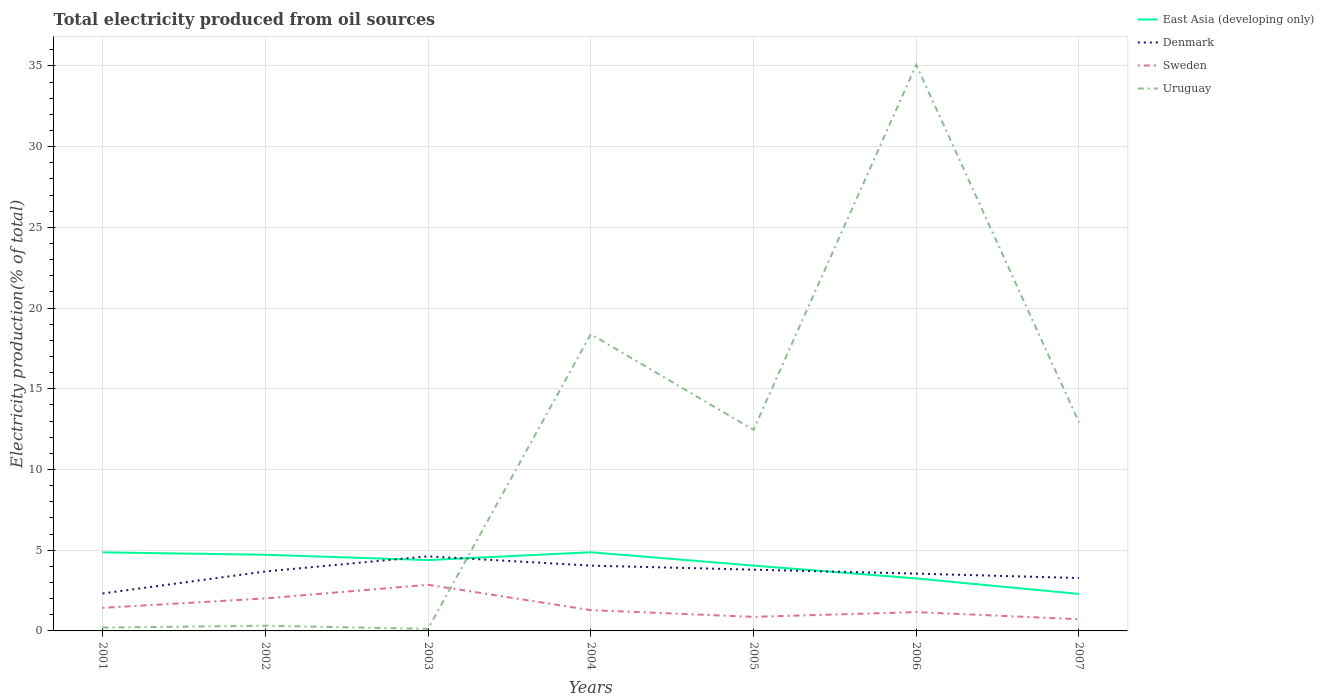Does the line corresponding to East Asia (developing only) intersect with the line corresponding to Uruguay?
Offer a terse response. Yes. Across all years, what is the maximum total electricity produced in East Asia (developing only)?
Give a very brief answer. 2.29. What is the total total electricity produced in Denmark in the graph?
Provide a short and direct response. -0.36. What is the difference between the highest and the second highest total electricity produced in Uruguay?
Make the answer very short. 34.94. Are the values on the major ticks of Y-axis written in scientific E-notation?
Make the answer very short. No. Does the graph contain any zero values?
Give a very brief answer. No. Does the graph contain grids?
Your answer should be very brief. Yes. Where does the legend appear in the graph?
Your response must be concise. Top right. What is the title of the graph?
Give a very brief answer. Total electricity produced from oil sources. What is the label or title of the X-axis?
Your answer should be very brief. Years. What is the Electricity production(% of total) in East Asia (developing only) in 2001?
Provide a short and direct response. 4.87. What is the Electricity production(% of total) in Denmark in 2001?
Offer a very short reply. 2.32. What is the Electricity production(% of total) of Sweden in 2001?
Provide a succinct answer. 1.43. What is the Electricity production(% of total) of Uruguay in 2001?
Your response must be concise. 0.21. What is the Electricity production(% of total) in East Asia (developing only) in 2002?
Make the answer very short. 4.72. What is the Electricity production(% of total) in Denmark in 2002?
Your answer should be very brief. 3.68. What is the Electricity production(% of total) in Sweden in 2002?
Your answer should be very brief. 2.01. What is the Electricity production(% of total) in Uruguay in 2002?
Keep it short and to the point. 0.32. What is the Electricity production(% of total) of East Asia (developing only) in 2003?
Your answer should be very brief. 4.39. What is the Electricity production(% of total) in Denmark in 2003?
Provide a short and direct response. 4.62. What is the Electricity production(% of total) in Sweden in 2003?
Your answer should be compact. 2.86. What is the Electricity production(% of total) in Uruguay in 2003?
Your answer should be compact. 0.13. What is the Electricity production(% of total) in East Asia (developing only) in 2004?
Provide a succinct answer. 4.87. What is the Electricity production(% of total) in Denmark in 2004?
Make the answer very short. 4.05. What is the Electricity production(% of total) in Sweden in 2004?
Provide a succinct answer. 1.29. What is the Electricity production(% of total) of Uruguay in 2004?
Your answer should be very brief. 18.38. What is the Electricity production(% of total) in East Asia (developing only) in 2005?
Offer a very short reply. 4.05. What is the Electricity production(% of total) of Denmark in 2005?
Offer a very short reply. 3.79. What is the Electricity production(% of total) of Sweden in 2005?
Give a very brief answer. 0.87. What is the Electricity production(% of total) in Uruguay in 2005?
Keep it short and to the point. 12.46. What is the Electricity production(% of total) of East Asia (developing only) in 2006?
Provide a short and direct response. 3.25. What is the Electricity production(% of total) in Denmark in 2006?
Provide a short and direct response. 3.55. What is the Electricity production(% of total) of Sweden in 2006?
Provide a short and direct response. 1.16. What is the Electricity production(% of total) of Uruguay in 2006?
Offer a terse response. 35.07. What is the Electricity production(% of total) of East Asia (developing only) in 2007?
Make the answer very short. 2.29. What is the Electricity production(% of total) in Denmark in 2007?
Provide a short and direct response. 3.28. What is the Electricity production(% of total) of Sweden in 2007?
Your answer should be very brief. 0.72. What is the Electricity production(% of total) of Uruguay in 2007?
Your response must be concise. 12.92. Across all years, what is the maximum Electricity production(% of total) in East Asia (developing only)?
Ensure brevity in your answer.  4.87. Across all years, what is the maximum Electricity production(% of total) of Denmark?
Make the answer very short. 4.62. Across all years, what is the maximum Electricity production(% of total) of Sweden?
Ensure brevity in your answer.  2.86. Across all years, what is the maximum Electricity production(% of total) of Uruguay?
Your answer should be very brief. 35.07. Across all years, what is the minimum Electricity production(% of total) of East Asia (developing only)?
Provide a succinct answer. 2.29. Across all years, what is the minimum Electricity production(% of total) of Denmark?
Your response must be concise. 2.32. Across all years, what is the minimum Electricity production(% of total) of Sweden?
Your answer should be very brief. 0.72. Across all years, what is the minimum Electricity production(% of total) of Uruguay?
Provide a succinct answer. 0.13. What is the total Electricity production(% of total) of East Asia (developing only) in the graph?
Offer a terse response. 28.44. What is the total Electricity production(% of total) in Denmark in the graph?
Offer a very short reply. 25.29. What is the total Electricity production(% of total) in Sweden in the graph?
Your response must be concise. 10.35. What is the total Electricity production(% of total) in Uruguay in the graph?
Ensure brevity in your answer.  79.49. What is the difference between the Electricity production(% of total) in East Asia (developing only) in 2001 and that in 2002?
Ensure brevity in your answer.  0.15. What is the difference between the Electricity production(% of total) of Denmark in 2001 and that in 2002?
Offer a terse response. -1.36. What is the difference between the Electricity production(% of total) of Sweden in 2001 and that in 2002?
Offer a terse response. -0.58. What is the difference between the Electricity production(% of total) in Uruguay in 2001 and that in 2002?
Make the answer very short. -0.12. What is the difference between the Electricity production(% of total) in East Asia (developing only) in 2001 and that in 2003?
Provide a short and direct response. 0.48. What is the difference between the Electricity production(% of total) of Denmark in 2001 and that in 2003?
Provide a short and direct response. -2.3. What is the difference between the Electricity production(% of total) in Sweden in 2001 and that in 2003?
Provide a short and direct response. -1.43. What is the difference between the Electricity production(% of total) in Uruguay in 2001 and that in 2003?
Offer a very short reply. 0.08. What is the difference between the Electricity production(% of total) in East Asia (developing only) in 2001 and that in 2004?
Your response must be concise. -0.01. What is the difference between the Electricity production(% of total) of Denmark in 2001 and that in 2004?
Your response must be concise. -1.73. What is the difference between the Electricity production(% of total) in Sweden in 2001 and that in 2004?
Your answer should be very brief. 0.14. What is the difference between the Electricity production(% of total) in Uruguay in 2001 and that in 2004?
Provide a short and direct response. -18.18. What is the difference between the Electricity production(% of total) of East Asia (developing only) in 2001 and that in 2005?
Give a very brief answer. 0.82. What is the difference between the Electricity production(% of total) of Denmark in 2001 and that in 2005?
Ensure brevity in your answer.  -1.47. What is the difference between the Electricity production(% of total) of Sweden in 2001 and that in 2005?
Your answer should be very brief. 0.56. What is the difference between the Electricity production(% of total) in Uruguay in 2001 and that in 2005?
Give a very brief answer. -12.25. What is the difference between the Electricity production(% of total) of East Asia (developing only) in 2001 and that in 2006?
Provide a short and direct response. 1.62. What is the difference between the Electricity production(% of total) of Denmark in 2001 and that in 2006?
Your response must be concise. -1.23. What is the difference between the Electricity production(% of total) in Sweden in 2001 and that in 2006?
Offer a very short reply. 0.26. What is the difference between the Electricity production(% of total) in Uruguay in 2001 and that in 2006?
Offer a terse response. -34.87. What is the difference between the Electricity production(% of total) in East Asia (developing only) in 2001 and that in 2007?
Give a very brief answer. 2.58. What is the difference between the Electricity production(% of total) of Denmark in 2001 and that in 2007?
Offer a terse response. -0.96. What is the difference between the Electricity production(% of total) in Sweden in 2001 and that in 2007?
Provide a short and direct response. 0.71. What is the difference between the Electricity production(% of total) of Uruguay in 2001 and that in 2007?
Offer a terse response. -12.72. What is the difference between the Electricity production(% of total) of East Asia (developing only) in 2002 and that in 2003?
Provide a succinct answer. 0.33. What is the difference between the Electricity production(% of total) of Denmark in 2002 and that in 2003?
Your answer should be compact. -0.94. What is the difference between the Electricity production(% of total) in Sweden in 2002 and that in 2003?
Ensure brevity in your answer.  -0.85. What is the difference between the Electricity production(% of total) of Uruguay in 2002 and that in 2003?
Your answer should be compact. 0.19. What is the difference between the Electricity production(% of total) in East Asia (developing only) in 2002 and that in 2004?
Make the answer very short. -0.15. What is the difference between the Electricity production(% of total) of Denmark in 2002 and that in 2004?
Make the answer very short. -0.36. What is the difference between the Electricity production(% of total) in Sweden in 2002 and that in 2004?
Make the answer very short. 0.73. What is the difference between the Electricity production(% of total) in Uruguay in 2002 and that in 2004?
Give a very brief answer. -18.06. What is the difference between the Electricity production(% of total) in East Asia (developing only) in 2002 and that in 2005?
Keep it short and to the point. 0.67. What is the difference between the Electricity production(% of total) of Denmark in 2002 and that in 2005?
Your answer should be compact. -0.11. What is the difference between the Electricity production(% of total) of Sweden in 2002 and that in 2005?
Provide a short and direct response. 1.14. What is the difference between the Electricity production(% of total) in Uruguay in 2002 and that in 2005?
Make the answer very short. -12.13. What is the difference between the Electricity production(% of total) of East Asia (developing only) in 2002 and that in 2006?
Provide a short and direct response. 1.47. What is the difference between the Electricity production(% of total) of Denmark in 2002 and that in 2006?
Your answer should be very brief. 0.13. What is the difference between the Electricity production(% of total) in Sweden in 2002 and that in 2006?
Provide a short and direct response. 0.85. What is the difference between the Electricity production(% of total) in Uruguay in 2002 and that in 2006?
Make the answer very short. -34.75. What is the difference between the Electricity production(% of total) in East Asia (developing only) in 2002 and that in 2007?
Offer a terse response. 2.43. What is the difference between the Electricity production(% of total) of Denmark in 2002 and that in 2007?
Your response must be concise. 0.41. What is the difference between the Electricity production(% of total) in Sweden in 2002 and that in 2007?
Your response must be concise. 1.29. What is the difference between the Electricity production(% of total) in Uruguay in 2002 and that in 2007?
Your answer should be compact. -12.6. What is the difference between the Electricity production(% of total) in East Asia (developing only) in 2003 and that in 2004?
Your answer should be very brief. -0.48. What is the difference between the Electricity production(% of total) in Denmark in 2003 and that in 2004?
Offer a very short reply. 0.57. What is the difference between the Electricity production(% of total) of Sweden in 2003 and that in 2004?
Your response must be concise. 1.57. What is the difference between the Electricity production(% of total) in Uruguay in 2003 and that in 2004?
Keep it short and to the point. -18.25. What is the difference between the Electricity production(% of total) of East Asia (developing only) in 2003 and that in 2005?
Make the answer very short. 0.34. What is the difference between the Electricity production(% of total) in Denmark in 2003 and that in 2005?
Make the answer very short. 0.83. What is the difference between the Electricity production(% of total) in Sweden in 2003 and that in 2005?
Make the answer very short. 1.99. What is the difference between the Electricity production(% of total) of Uruguay in 2003 and that in 2005?
Your response must be concise. -12.33. What is the difference between the Electricity production(% of total) in East Asia (developing only) in 2003 and that in 2006?
Provide a succinct answer. 1.14. What is the difference between the Electricity production(% of total) in Denmark in 2003 and that in 2006?
Offer a very short reply. 1.07. What is the difference between the Electricity production(% of total) in Sweden in 2003 and that in 2006?
Provide a short and direct response. 1.69. What is the difference between the Electricity production(% of total) in Uruguay in 2003 and that in 2006?
Offer a very short reply. -34.94. What is the difference between the Electricity production(% of total) in East Asia (developing only) in 2003 and that in 2007?
Offer a very short reply. 2.1. What is the difference between the Electricity production(% of total) of Denmark in 2003 and that in 2007?
Provide a short and direct response. 1.34. What is the difference between the Electricity production(% of total) of Sweden in 2003 and that in 2007?
Provide a succinct answer. 2.14. What is the difference between the Electricity production(% of total) in Uruguay in 2003 and that in 2007?
Offer a terse response. -12.79. What is the difference between the Electricity production(% of total) in East Asia (developing only) in 2004 and that in 2005?
Your answer should be very brief. 0.83. What is the difference between the Electricity production(% of total) in Denmark in 2004 and that in 2005?
Make the answer very short. 0.25. What is the difference between the Electricity production(% of total) of Sweden in 2004 and that in 2005?
Ensure brevity in your answer.  0.42. What is the difference between the Electricity production(% of total) of Uruguay in 2004 and that in 2005?
Your response must be concise. 5.92. What is the difference between the Electricity production(% of total) in East Asia (developing only) in 2004 and that in 2006?
Offer a terse response. 1.62. What is the difference between the Electricity production(% of total) of Denmark in 2004 and that in 2006?
Ensure brevity in your answer.  0.5. What is the difference between the Electricity production(% of total) of Sweden in 2004 and that in 2006?
Ensure brevity in your answer.  0.12. What is the difference between the Electricity production(% of total) in Uruguay in 2004 and that in 2006?
Your response must be concise. -16.69. What is the difference between the Electricity production(% of total) of East Asia (developing only) in 2004 and that in 2007?
Give a very brief answer. 2.58. What is the difference between the Electricity production(% of total) in Denmark in 2004 and that in 2007?
Offer a terse response. 0.77. What is the difference between the Electricity production(% of total) in Sweden in 2004 and that in 2007?
Provide a succinct answer. 0.56. What is the difference between the Electricity production(% of total) of Uruguay in 2004 and that in 2007?
Offer a terse response. 5.46. What is the difference between the Electricity production(% of total) in East Asia (developing only) in 2005 and that in 2006?
Keep it short and to the point. 0.8. What is the difference between the Electricity production(% of total) of Denmark in 2005 and that in 2006?
Your answer should be compact. 0.24. What is the difference between the Electricity production(% of total) of Sweden in 2005 and that in 2006?
Offer a terse response. -0.29. What is the difference between the Electricity production(% of total) in Uruguay in 2005 and that in 2006?
Provide a short and direct response. -22.61. What is the difference between the Electricity production(% of total) of East Asia (developing only) in 2005 and that in 2007?
Keep it short and to the point. 1.76. What is the difference between the Electricity production(% of total) in Denmark in 2005 and that in 2007?
Keep it short and to the point. 0.52. What is the difference between the Electricity production(% of total) in Sweden in 2005 and that in 2007?
Keep it short and to the point. 0.15. What is the difference between the Electricity production(% of total) in Uruguay in 2005 and that in 2007?
Ensure brevity in your answer.  -0.46. What is the difference between the Electricity production(% of total) in East Asia (developing only) in 2006 and that in 2007?
Offer a terse response. 0.96. What is the difference between the Electricity production(% of total) in Denmark in 2006 and that in 2007?
Keep it short and to the point. 0.27. What is the difference between the Electricity production(% of total) in Sweden in 2006 and that in 2007?
Offer a terse response. 0.44. What is the difference between the Electricity production(% of total) of Uruguay in 2006 and that in 2007?
Keep it short and to the point. 22.15. What is the difference between the Electricity production(% of total) in East Asia (developing only) in 2001 and the Electricity production(% of total) in Denmark in 2002?
Your answer should be very brief. 1.18. What is the difference between the Electricity production(% of total) of East Asia (developing only) in 2001 and the Electricity production(% of total) of Sweden in 2002?
Ensure brevity in your answer.  2.85. What is the difference between the Electricity production(% of total) of East Asia (developing only) in 2001 and the Electricity production(% of total) of Uruguay in 2002?
Provide a short and direct response. 4.54. What is the difference between the Electricity production(% of total) of Denmark in 2001 and the Electricity production(% of total) of Sweden in 2002?
Your response must be concise. 0.3. What is the difference between the Electricity production(% of total) of Denmark in 2001 and the Electricity production(% of total) of Uruguay in 2002?
Keep it short and to the point. 2. What is the difference between the Electricity production(% of total) in Sweden in 2001 and the Electricity production(% of total) in Uruguay in 2002?
Provide a short and direct response. 1.11. What is the difference between the Electricity production(% of total) of East Asia (developing only) in 2001 and the Electricity production(% of total) of Denmark in 2003?
Offer a very short reply. 0.25. What is the difference between the Electricity production(% of total) in East Asia (developing only) in 2001 and the Electricity production(% of total) in Sweden in 2003?
Ensure brevity in your answer.  2.01. What is the difference between the Electricity production(% of total) in East Asia (developing only) in 2001 and the Electricity production(% of total) in Uruguay in 2003?
Your answer should be very brief. 4.74. What is the difference between the Electricity production(% of total) in Denmark in 2001 and the Electricity production(% of total) in Sweden in 2003?
Offer a terse response. -0.54. What is the difference between the Electricity production(% of total) in Denmark in 2001 and the Electricity production(% of total) in Uruguay in 2003?
Keep it short and to the point. 2.19. What is the difference between the Electricity production(% of total) of Sweden in 2001 and the Electricity production(% of total) of Uruguay in 2003?
Provide a succinct answer. 1.3. What is the difference between the Electricity production(% of total) in East Asia (developing only) in 2001 and the Electricity production(% of total) in Denmark in 2004?
Offer a terse response. 0.82. What is the difference between the Electricity production(% of total) in East Asia (developing only) in 2001 and the Electricity production(% of total) in Sweden in 2004?
Your answer should be very brief. 3.58. What is the difference between the Electricity production(% of total) of East Asia (developing only) in 2001 and the Electricity production(% of total) of Uruguay in 2004?
Your answer should be compact. -13.51. What is the difference between the Electricity production(% of total) in Denmark in 2001 and the Electricity production(% of total) in Sweden in 2004?
Your response must be concise. 1.03. What is the difference between the Electricity production(% of total) in Denmark in 2001 and the Electricity production(% of total) in Uruguay in 2004?
Keep it short and to the point. -16.06. What is the difference between the Electricity production(% of total) of Sweden in 2001 and the Electricity production(% of total) of Uruguay in 2004?
Your answer should be very brief. -16.95. What is the difference between the Electricity production(% of total) in East Asia (developing only) in 2001 and the Electricity production(% of total) in Denmark in 2005?
Provide a short and direct response. 1.07. What is the difference between the Electricity production(% of total) of East Asia (developing only) in 2001 and the Electricity production(% of total) of Sweden in 2005?
Make the answer very short. 4. What is the difference between the Electricity production(% of total) in East Asia (developing only) in 2001 and the Electricity production(% of total) in Uruguay in 2005?
Give a very brief answer. -7.59. What is the difference between the Electricity production(% of total) in Denmark in 2001 and the Electricity production(% of total) in Sweden in 2005?
Provide a short and direct response. 1.45. What is the difference between the Electricity production(% of total) of Denmark in 2001 and the Electricity production(% of total) of Uruguay in 2005?
Your answer should be compact. -10.14. What is the difference between the Electricity production(% of total) of Sweden in 2001 and the Electricity production(% of total) of Uruguay in 2005?
Make the answer very short. -11.03. What is the difference between the Electricity production(% of total) of East Asia (developing only) in 2001 and the Electricity production(% of total) of Denmark in 2006?
Keep it short and to the point. 1.32. What is the difference between the Electricity production(% of total) of East Asia (developing only) in 2001 and the Electricity production(% of total) of Sweden in 2006?
Keep it short and to the point. 3.7. What is the difference between the Electricity production(% of total) in East Asia (developing only) in 2001 and the Electricity production(% of total) in Uruguay in 2006?
Your response must be concise. -30.2. What is the difference between the Electricity production(% of total) in Denmark in 2001 and the Electricity production(% of total) in Sweden in 2006?
Make the answer very short. 1.15. What is the difference between the Electricity production(% of total) in Denmark in 2001 and the Electricity production(% of total) in Uruguay in 2006?
Provide a short and direct response. -32.75. What is the difference between the Electricity production(% of total) in Sweden in 2001 and the Electricity production(% of total) in Uruguay in 2006?
Keep it short and to the point. -33.64. What is the difference between the Electricity production(% of total) of East Asia (developing only) in 2001 and the Electricity production(% of total) of Denmark in 2007?
Offer a very short reply. 1.59. What is the difference between the Electricity production(% of total) of East Asia (developing only) in 2001 and the Electricity production(% of total) of Sweden in 2007?
Your response must be concise. 4.14. What is the difference between the Electricity production(% of total) in East Asia (developing only) in 2001 and the Electricity production(% of total) in Uruguay in 2007?
Your response must be concise. -8.05. What is the difference between the Electricity production(% of total) in Denmark in 2001 and the Electricity production(% of total) in Sweden in 2007?
Your response must be concise. 1.6. What is the difference between the Electricity production(% of total) of Denmark in 2001 and the Electricity production(% of total) of Uruguay in 2007?
Ensure brevity in your answer.  -10.6. What is the difference between the Electricity production(% of total) in Sweden in 2001 and the Electricity production(% of total) in Uruguay in 2007?
Give a very brief answer. -11.49. What is the difference between the Electricity production(% of total) of East Asia (developing only) in 2002 and the Electricity production(% of total) of Denmark in 2003?
Offer a very short reply. 0.1. What is the difference between the Electricity production(% of total) of East Asia (developing only) in 2002 and the Electricity production(% of total) of Sweden in 2003?
Offer a very short reply. 1.86. What is the difference between the Electricity production(% of total) in East Asia (developing only) in 2002 and the Electricity production(% of total) in Uruguay in 2003?
Keep it short and to the point. 4.59. What is the difference between the Electricity production(% of total) in Denmark in 2002 and the Electricity production(% of total) in Sweden in 2003?
Make the answer very short. 0.82. What is the difference between the Electricity production(% of total) of Denmark in 2002 and the Electricity production(% of total) of Uruguay in 2003?
Keep it short and to the point. 3.55. What is the difference between the Electricity production(% of total) in Sweden in 2002 and the Electricity production(% of total) in Uruguay in 2003?
Offer a terse response. 1.89. What is the difference between the Electricity production(% of total) in East Asia (developing only) in 2002 and the Electricity production(% of total) in Denmark in 2004?
Your answer should be compact. 0.67. What is the difference between the Electricity production(% of total) of East Asia (developing only) in 2002 and the Electricity production(% of total) of Sweden in 2004?
Give a very brief answer. 3.43. What is the difference between the Electricity production(% of total) of East Asia (developing only) in 2002 and the Electricity production(% of total) of Uruguay in 2004?
Provide a succinct answer. -13.66. What is the difference between the Electricity production(% of total) of Denmark in 2002 and the Electricity production(% of total) of Sweden in 2004?
Provide a short and direct response. 2.39. What is the difference between the Electricity production(% of total) in Denmark in 2002 and the Electricity production(% of total) in Uruguay in 2004?
Your answer should be very brief. -14.7. What is the difference between the Electricity production(% of total) in Sweden in 2002 and the Electricity production(% of total) in Uruguay in 2004?
Your response must be concise. -16.37. What is the difference between the Electricity production(% of total) in East Asia (developing only) in 2002 and the Electricity production(% of total) in Denmark in 2005?
Your answer should be very brief. 0.93. What is the difference between the Electricity production(% of total) of East Asia (developing only) in 2002 and the Electricity production(% of total) of Sweden in 2005?
Your response must be concise. 3.85. What is the difference between the Electricity production(% of total) in East Asia (developing only) in 2002 and the Electricity production(% of total) in Uruguay in 2005?
Your answer should be very brief. -7.74. What is the difference between the Electricity production(% of total) in Denmark in 2002 and the Electricity production(% of total) in Sweden in 2005?
Provide a succinct answer. 2.81. What is the difference between the Electricity production(% of total) of Denmark in 2002 and the Electricity production(% of total) of Uruguay in 2005?
Provide a succinct answer. -8.77. What is the difference between the Electricity production(% of total) of Sweden in 2002 and the Electricity production(% of total) of Uruguay in 2005?
Keep it short and to the point. -10.44. What is the difference between the Electricity production(% of total) in East Asia (developing only) in 2002 and the Electricity production(% of total) in Denmark in 2006?
Offer a very short reply. 1.17. What is the difference between the Electricity production(% of total) in East Asia (developing only) in 2002 and the Electricity production(% of total) in Sweden in 2006?
Your response must be concise. 3.55. What is the difference between the Electricity production(% of total) of East Asia (developing only) in 2002 and the Electricity production(% of total) of Uruguay in 2006?
Make the answer very short. -30.35. What is the difference between the Electricity production(% of total) of Denmark in 2002 and the Electricity production(% of total) of Sweden in 2006?
Keep it short and to the point. 2.52. What is the difference between the Electricity production(% of total) of Denmark in 2002 and the Electricity production(% of total) of Uruguay in 2006?
Ensure brevity in your answer.  -31.39. What is the difference between the Electricity production(% of total) in Sweden in 2002 and the Electricity production(% of total) in Uruguay in 2006?
Keep it short and to the point. -33.06. What is the difference between the Electricity production(% of total) in East Asia (developing only) in 2002 and the Electricity production(% of total) in Denmark in 2007?
Provide a short and direct response. 1.44. What is the difference between the Electricity production(% of total) in East Asia (developing only) in 2002 and the Electricity production(% of total) in Sweden in 2007?
Ensure brevity in your answer.  4. What is the difference between the Electricity production(% of total) in East Asia (developing only) in 2002 and the Electricity production(% of total) in Uruguay in 2007?
Keep it short and to the point. -8.2. What is the difference between the Electricity production(% of total) in Denmark in 2002 and the Electricity production(% of total) in Sweden in 2007?
Your response must be concise. 2.96. What is the difference between the Electricity production(% of total) of Denmark in 2002 and the Electricity production(% of total) of Uruguay in 2007?
Make the answer very short. -9.24. What is the difference between the Electricity production(% of total) of Sweden in 2002 and the Electricity production(% of total) of Uruguay in 2007?
Make the answer very short. -10.91. What is the difference between the Electricity production(% of total) in East Asia (developing only) in 2003 and the Electricity production(% of total) in Denmark in 2004?
Your response must be concise. 0.34. What is the difference between the Electricity production(% of total) of East Asia (developing only) in 2003 and the Electricity production(% of total) of Sweden in 2004?
Ensure brevity in your answer.  3.1. What is the difference between the Electricity production(% of total) in East Asia (developing only) in 2003 and the Electricity production(% of total) in Uruguay in 2004?
Give a very brief answer. -13.99. What is the difference between the Electricity production(% of total) in Denmark in 2003 and the Electricity production(% of total) in Sweden in 2004?
Keep it short and to the point. 3.33. What is the difference between the Electricity production(% of total) in Denmark in 2003 and the Electricity production(% of total) in Uruguay in 2004?
Keep it short and to the point. -13.76. What is the difference between the Electricity production(% of total) of Sweden in 2003 and the Electricity production(% of total) of Uruguay in 2004?
Give a very brief answer. -15.52. What is the difference between the Electricity production(% of total) of East Asia (developing only) in 2003 and the Electricity production(% of total) of Denmark in 2005?
Ensure brevity in your answer.  0.6. What is the difference between the Electricity production(% of total) of East Asia (developing only) in 2003 and the Electricity production(% of total) of Sweden in 2005?
Ensure brevity in your answer.  3.52. What is the difference between the Electricity production(% of total) of East Asia (developing only) in 2003 and the Electricity production(% of total) of Uruguay in 2005?
Provide a short and direct response. -8.07. What is the difference between the Electricity production(% of total) in Denmark in 2003 and the Electricity production(% of total) in Sweden in 2005?
Give a very brief answer. 3.75. What is the difference between the Electricity production(% of total) of Denmark in 2003 and the Electricity production(% of total) of Uruguay in 2005?
Your answer should be compact. -7.84. What is the difference between the Electricity production(% of total) in Sweden in 2003 and the Electricity production(% of total) in Uruguay in 2005?
Your answer should be compact. -9.6. What is the difference between the Electricity production(% of total) of East Asia (developing only) in 2003 and the Electricity production(% of total) of Denmark in 2006?
Your answer should be compact. 0.84. What is the difference between the Electricity production(% of total) of East Asia (developing only) in 2003 and the Electricity production(% of total) of Sweden in 2006?
Keep it short and to the point. 3.22. What is the difference between the Electricity production(% of total) in East Asia (developing only) in 2003 and the Electricity production(% of total) in Uruguay in 2006?
Offer a terse response. -30.68. What is the difference between the Electricity production(% of total) in Denmark in 2003 and the Electricity production(% of total) in Sweden in 2006?
Your response must be concise. 3.46. What is the difference between the Electricity production(% of total) of Denmark in 2003 and the Electricity production(% of total) of Uruguay in 2006?
Offer a very short reply. -30.45. What is the difference between the Electricity production(% of total) of Sweden in 2003 and the Electricity production(% of total) of Uruguay in 2006?
Provide a short and direct response. -32.21. What is the difference between the Electricity production(% of total) in East Asia (developing only) in 2003 and the Electricity production(% of total) in Denmark in 2007?
Provide a succinct answer. 1.11. What is the difference between the Electricity production(% of total) of East Asia (developing only) in 2003 and the Electricity production(% of total) of Sweden in 2007?
Ensure brevity in your answer.  3.66. What is the difference between the Electricity production(% of total) in East Asia (developing only) in 2003 and the Electricity production(% of total) in Uruguay in 2007?
Your response must be concise. -8.53. What is the difference between the Electricity production(% of total) in Denmark in 2003 and the Electricity production(% of total) in Sweden in 2007?
Provide a succinct answer. 3.9. What is the difference between the Electricity production(% of total) in Denmark in 2003 and the Electricity production(% of total) in Uruguay in 2007?
Ensure brevity in your answer.  -8.3. What is the difference between the Electricity production(% of total) in Sweden in 2003 and the Electricity production(% of total) in Uruguay in 2007?
Make the answer very short. -10.06. What is the difference between the Electricity production(% of total) of East Asia (developing only) in 2004 and the Electricity production(% of total) of Denmark in 2005?
Offer a terse response. 1.08. What is the difference between the Electricity production(% of total) of East Asia (developing only) in 2004 and the Electricity production(% of total) of Sweden in 2005?
Your answer should be compact. 4. What is the difference between the Electricity production(% of total) in East Asia (developing only) in 2004 and the Electricity production(% of total) in Uruguay in 2005?
Keep it short and to the point. -7.58. What is the difference between the Electricity production(% of total) in Denmark in 2004 and the Electricity production(% of total) in Sweden in 2005?
Your answer should be very brief. 3.18. What is the difference between the Electricity production(% of total) in Denmark in 2004 and the Electricity production(% of total) in Uruguay in 2005?
Provide a short and direct response. -8.41. What is the difference between the Electricity production(% of total) of Sweden in 2004 and the Electricity production(% of total) of Uruguay in 2005?
Your answer should be very brief. -11.17. What is the difference between the Electricity production(% of total) of East Asia (developing only) in 2004 and the Electricity production(% of total) of Denmark in 2006?
Your answer should be very brief. 1.32. What is the difference between the Electricity production(% of total) of East Asia (developing only) in 2004 and the Electricity production(% of total) of Sweden in 2006?
Provide a succinct answer. 3.71. What is the difference between the Electricity production(% of total) in East Asia (developing only) in 2004 and the Electricity production(% of total) in Uruguay in 2006?
Offer a very short reply. -30.2. What is the difference between the Electricity production(% of total) of Denmark in 2004 and the Electricity production(% of total) of Sweden in 2006?
Provide a short and direct response. 2.88. What is the difference between the Electricity production(% of total) of Denmark in 2004 and the Electricity production(% of total) of Uruguay in 2006?
Your answer should be very brief. -31.03. What is the difference between the Electricity production(% of total) of Sweden in 2004 and the Electricity production(% of total) of Uruguay in 2006?
Provide a short and direct response. -33.78. What is the difference between the Electricity production(% of total) in East Asia (developing only) in 2004 and the Electricity production(% of total) in Denmark in 2007?
Give a very brief answer. 1.6. What is the difference between the Electricity production(% of total) of East Asia (developing only) in 2004 and the Electricity production(% of total) of Sweden in 2007?
Your answer should be very brief. 4.15. What is the difference between the Electricity production(% of total) of East Asia (developing only) in 2004 and the Electricity production(% of total) of Uruguay in 2007?
Keep it short and to the point. -8.05. What is the difference between the Electricity production(% of total) in Denmark in 2004 and the Electricity production(% of total) in Sweden in 2007?
Provide a succinct answer. 3.32. What is the difference between the Electricity production(% of total) in Denmark in 2004 and the Electricity production(% of total) in Uruguay in 2007?
Provide a succinct answer. -8.88. What is the difference between the Electricity production(% of total) in Sweden in 2004 and the Electricity production(% of total) in Uruguay in 2007?
Your response must be concise. -11.63. What is the difference between the Electricity production(% of total) in East Asia (developing only) in 2005 and the Electricity production(% of total) in Denmark in 2006?
Ensure brevity in your answer.  0.5. What is the difference between the Electricity production(% of total) in East Asia (developing only) in 2005 and the Electricity production(% of total) in Sweden in 2006?
Your response must be concise. 2.88. What is the difference between the Electricity production(% of total) of East Asia (developing only) in 2005 and the Electricity production(% of total) of Uruguay in 2006?
Ensure brevity in your answer.  -31.03. What is the difference between the Electricity production(% of total) in Denmark in 2005 and the Electricity production(% of total) in Sweden in 2006?
Your answer should be compact. 2.63. What is the difference between the Electricity production(% of total) of Denmark in 2005 and the Electricity production(% of total) of Uruguay in 2006?
Ensure brevity in your answer.  -31.28. What is the difference between the Electricity production(% of total) of Sweden in 2005 and the Electricity production(% of total) of Uruguay in 2006?
Ensure brevity in your answer.  -34.2. What is the difference between the Electricity production(% of total) of East Asia (developing only) in 2005 and the Electricity production(% of total) of Denmark in 2007?
Offer a very short reply. 0.77. What is the difference between the Electricity production(% of total) in East Asia (developing only) in 2005 and the Electricity production(% of total) in Sweden in 2007?
Keep it short and to the point. 3.32. What is the difference between the Electricity production(% of total) in East Asia (developing only) in 2005 and the Electricity production(% of total) in Uruguay in 2007?
Provide a succinct answer. -8.88. What is the difference between the Electricity production(% of total) in Denmark in 2005 and the Electricity production(% of total) in Sweden in 2007?
Offer a terse response. 3.07. What is the difference between the Electricity production(% of total) of Denmark in 2005 and the Electricity production(% of total) of Uruguay in 2007?
Offer a very short reply. -9.13. What is the difference between the Electricity production(% of total) in Sweden in 2005 and the Electricity production(% of total) in Uruguay in 2007?
Give a very brief answer. -12.05. What is the difference between the Electricity production(% of total) in East Asia (developing only) in 2006 and the Electricity production(% of total) in Denmark in 2007?
Your answer should be very brief. -0.03. What is the difference between the Electricity production(% of total) in East Asia (developing only) in 2006 and the Electricity production(% of total) in Sweden in 2007?
Make the answer very short. 2.53. What is the difference between the Electricity production(% of total) of East Asia (developing only) in 2006 and the Electricity production(% of total) of Uruguay in 2007?
Offer a very short reply. -9.67. What is the difference between the Electricity production(% of total) of Denmark in 2006 and the Electricity production(% of total) of Sweden in 2007?
Give a very brief answer. 2.83. What is the difference between the Electricity production(% of total) in Denmark in 2006 and the Electricity production(% of total) in Uruguay in 2007?
Offer a very short reply. -9.37. What is the difference between the Electricity production(% of total) of Sweden in 2006 and the Electricity production(% of total) of Uruguay in 2007?
Offer a terse response. -11.76. What is the average Electricity production(% of total) in East Asia (developing only) per year?
Make the answer very short. 4.06. What is the average Electricity production(% of total) of Denmark per year?
Ensure brevity in your answer.  3.61. What is the average Electricity production(% of total) in Sweden per year?
Your answer should be very brief. 1.48. What is the average Electricity production(% of total) in Uruguay per year?
Provide a succinct answer. 11.36. In the year 2001, what is the difference between the Electricity production(% of total) in East Asia (developing only) and Electricity production(% of total) in Denmark?
Your answer should be very brief. 2.55. In the year 2001, what is the difference between the Electricity production(% of total) in East Asia (developing only) and Electricity production(% of total) in Sweden?
Offer a terse response. 3.44. In the year 2001, what is the difference between the Electricity production(% of total) of East Asia (developing only) and Electricity production(% of total) of Uruguay?
Provide a succinct answer. 4.66. In the year 2001, what is the difference between the Electricity production(% of total) of Denmark and Electricity production(% of total) of Sweden?
Your answer should be compact. 0.89. In the year 2001, what is the difference between the Electricity production(% of total) in Denmark and Electricity production(% of total) in Uruguay?
Your response must be concise. 2.11. In the year 2001, what is the difference between the Electricity production(% of total) in Sweden and Electricity production(% of total) in Uruguay?
Ensure brevity in your answer.  1.22. In the year 2002, what is the difference between the Electricity production(% of total) of East Asia (developing only) and Electricity production(% of total) of Denmark?
Your answer should be very brief. 1.04. In the year 2002, what is the difference between the Electricity production(% of total) in East Asia (developing only) and Electricity production(% of total) in Sweden?
Offer a very short reply. 2.7. In the year 2002, what is the difference between the Electricity production(% of total) in East Asia (developing only) and Electricity production(% of total) in Uruguay?
Offer a very short reply. 4.4. In the year 2002, what is the difference between the Electricity production(% of total) of Denmark and Electricity production(% of total) of Sweden?
Provide a short and direct response. 1.67. In the year 2002, what is the difference between the Electricity production(% of total) of Denmark and Electricity production(% of total) of Uruguay?
Give a very brief answer. 3.36. In the year 2002, what is the difference between the Electricity production(% of total) of Sweden and Electricity production(% of total) of Uruguay?
Make the answer very short. 1.69. In the year 2003, what is the difference between the Electricity production(% of total) in East Asia (developing only) and Electricity production(% of total) in Denmark?
Keep it short and to the point. -0.23. In the year 2003, what is the difference between the Electricity production(% of total) of East Asia (developing only) and Electricity production(% of total) of Sweden?
Give a very brief answer. 1.53. In the year 2003, what is the difference between the Electricity production(% of total) of East Asia (developing only) and Electricity production(% of total) of Uruguay?
Your response must be concise. 4.26. In the year 2003, what is the difference between the Electricity production(% of total) in Denmark and Electricity production(% of total) in Sweden?
Offer a very short reply. 1.76. In the year 2003, what is the difference between the Electricity production(% of total) in Denmark and Electricity production(% of total) in Uruguay?
Your answer should be compact. 4.49. In the year 2003, what is the difference between the Electricity production(% of total) of Sweden and Electricity production(% of total) of Uruguay?
Make the answer very short. 2.73. In the year 2004, what is the difference between the Electricity production(% of total) in East Asia (developing only) and Electricity production(% of total) in Denmark?
Provide a succinct answer. 0.83. In the year 2004, what is the difference between the Electricity production(% of total) in East Asia (developing only) and Electricity production(% of total) in Sweden?
Keep it short and to the point. 3.59. In the year 2004, what is the difference between the Electricity production(% of total) in East Asia (developing only) and Electricity production(% of total) in Uruguay?
Your response must be concise. -13.51. In the year 2004, what is the difference between the Electricity production(% of total) of Denmark and Electricity production(% of total) of Sweden?
Offer a very short reply. 2.76. In the year 2004, what is the difference between the Electricity production(% of total) of Denmark and Electricity production(% of total) of Uruguay?
Ensure brevity in your answer.  -14.34. In the year 2004, what is the difference between the Electricity production(% of total) in Sweden and Electricity production(% of total) in Uruguay?
Offer a terse response. -17.09. In the year 2005, what is the difference between the Electricity production(% of total) of East Asia (developing only) and Electricity production(% of total) of Denmark?
Your answer should be very brief. 0.25. In the year 2005, what is the difference between the Electricity production(% of total) of East Asia (developing only) and Electricity production(% of total) of Sweden?
Offer a terse response. 3.18. In the year 2005, what is the difference between the Electricity production(% of total) of East Asia (developing only) and Electricity production(% of total) of Uruguay?
Your answer should be very brief. -8.41. In the year 2005, what is the difference between the Electricity production(% of total) in Denmark and Electricity production(% of total) in Sweden?
Provide a succinct answer. 2.92. In the year 2005, what is the difference between the Electricity production(% of total) in Denmark and Electricity production(% of total) in Uruguay?
Your response must be concise. -8.66. In the year 2005, what is the difference between the Electricity production(% of total) in Sweden and Electricity production(% of total) in Uruguay?
Keep it short and to the point. -11.59. In the year 2006, what is the difference between the Electricity production(% of total) of East Asia (developing only) and Electricity production(% of total) of Denmark?
Provide a short and direct response. -0.3. In the year 2006, what is the difference between the Electricity production(% of total) of East Asia (developing only) and Electricity production(% of total) of Sweden?
Make the answer very short. 2.09. In the year 2006, what is the difference between the Electricity production(% of total) in East Asia (developing only) and Electricity production(% of total) in Uruguay?
Keep it short and to the point. -31.82. In the year 2006, what is the difference between the Electricity production(% of total) of Denmark and Electricity production(% of total) of Sweden?
Keep it short and to the point. 2.38. In the year 2006, what is the difference between the Electricity production(% of total) of Denmark and Electricity production(% of total) of Uruguay?
Keep it short and to the point. -31.52. In the year 2006, what is the difference between the Electricity production(% of total) of Sweden and Electricity production(% of total) of Uruguay?
Your answer should be compact. -33.91. In the year 2007, what is the difference between the Electricity production(% of total) in East Asia (developing only) and Electricity production(% of total) in Denmark?
Make the answer very short. -0.98. In the year 2007, what is the difference between the Electricity production(% of total) of East Asia (developing only) and Electricity production(% of total) of Sweden?
Your response must be concise. 1.57. In the year 2007, what is the difference between the Electricity production(% of total) of East Asia (developing only) and Electricity production(% of total) of Uruguay?
Provide a succinct answer. -10.63. In the year 2007, what is the difference between the Electricity production(% of total) in Denmark and Electricity production(% of total) in Sweden?
Your response must be concise. 2.55. In the year 2007, what is the difference between the Electricity production(% of total) in Denmark and Electricity production(% of total) in Uruguay?
Give a very brief answer. -9.65. In the year 2007, what is the difference between the Electricity production(% of total) of Sweden and Electricity production(% of total) of Uruguay?
Provide a succinct answer. -12.2. What is the ratio of the Electricity production(% of total) of East Asia (developing only) in 2001 to that in 2002?
Provide a short and direct response. 1.03. What is the ratio of the Electricity production(% of total) in Denmark in 2001 to that in 2002?
Your answer should be very brief. 0.63. What is the ratio of the Electricity production(% of total) in Sweden in 2001 to that in 2002?
Ensure brevity in your answer.  0.71. What is the ratio of the Electricity production(% of total) in Uruguay in 2001 to that in 2002?
Give a very brief answer. 0.64. What is the ratio of the Electricity production(% of total) of East Asia (developing only) in 2001 to that in 2003?
Keep it short and to the point. 1.11. What is the ratio of the Electricity production(% of total) in Denmark in 2001 to that in 2003?
Provide a succinct answer. 0.5. What is the ratio of the Electricity production(% of total) of Sweden in 2001 to that in 2003?
Provide a short and direct response. 0.5. What is the ratio of the Electricity production(% of total) of Uruguay in 2001 to that in 2003?
Your answer should be compact. 1.6. What is the ratio of the Electricity production(% of total) of Denmark in 2001 to that in 2004?
Make the answer very short. 0.57. What is the ratio of the Electricity production(% of total) of Sweden in 2001 to that in 2004?
Your answer should be compact. 1.11. What is the ratio of the Electricity production(% of total) of Uruguay in 2001 to that in 2004?
Give a very brief answer. 0.01. What is the ratio of the Electricity production(% of total) in East Asia (developing only) in 2001 to that in 2005?
Your answer should be very brief. 1.2. What is the ratio of the Electricity production(% of total) in Denmark in 2001 to that in 2005?
Keep it short and to the point. 0.61. What is the ratio of the Electricity production(% of total) of Sweden in 2001 to that in 2005?
Keep it short and to the point. 1.64. What is the ratio of the Electricity production(% of total) in Uruguay in 2001 to that in 2005?
Ensure brevity in your answer.  0.02. What is the ratio of the Electricity production(% of total) in East Asia (developing only) in 2001 to that in 2006?
Ensure brevity in your answer.  1.5. What is the ratio of the Electricity production(% of total) of Denmark in 2001 to that in 2006?
Your answer should be compact. 0.65. What is the ratio of the Electricity production(% of total) of Sweden in 2001 to that in 2006?
Your answer should be very brief. 1.23. What is the ratio of the Electricity production(% of total) of Uruguay in 2001 to that in 2006?
Offer a very short reply. 0.01. What is the ratio of the Electricity production(% of total) of East Asia (developing only) in 2001 to that in 2007?
Make the answer very short. 2.12. What is the ratio of the Electricity production(% of total) in Denmark in 2001 to that in 2007?
Provide a short and direct response. 0.71. What is the ratio of the Electricity production(% of total) in Sweden in 2001 to that in 2007?
Offer a terse response. 1.98. What is the ratio of the Electricity production(% of total) in Uruguay in 2001 to that in 2007?
Your response must be concise. 0.02. What is the ratio of the Electricity production(% of total) of East Asia (developing only) in 2002 to that in 2003?
Offer a very short reply. 1.08. What is the ratio of the Electricity production(% of total) of Denmark in 2002 to that in 2003?
Your answer should be very brief. 0.8. What is the ratio of the Electricity production(% of total) in Sweden in 2002 to that in 2003?
Provide a succinct answer. 0.7. What is the ratio of the Electricity production(% of total) in Uruguay in 2002 to that in 2003?
Provide a short and direct response. 2.52. What is the ratio of the Electricity production(% of total) in East Asia (developing only) in 2002 to that in 2004?
Your response must be concise. 0.97. What is the ratio of the Electricity production(% of total) of Denmark in 2002 to that in 2004?
Offer a terse response. 0.91. What is the ratio of the Electricity production(% of total) in Sweden in 2002 to that in 2004?
Provide a succinct answer. 1.56. What is the ratio of the Electricity production(% of total) in Uruguay in 2002 to that in 2004?
Keep it short and to the point. 0.02. What is the ratio of the Electricity production(% of total) of East Asia (developing only) in 2002 to that in 2005?
Make the answer very short. 1.17. What is the ratio of the Electricity production(% of total) in Denmark in 2002 to that in 2005?
Provide a short and direct response. 0.97. What is the ratio of the Electricity production(% of total) of Sweden in 2002 to that in 2005?
Your answer should be very brief. 2.31. What is the ratio of the Electricity production(% of total) in Uruguay in 2002 to that in 2005?
Your answer should be very brief. 0.03. What is the ratio of the Electricity production(% of total) of East Asia (developing only) in 2002 to that in 2006?
Keep it short and to the point. 1.45. What is the ratio of the Electricity production(% of total) of Denmark in 2002 to that in 2006?
Provide a short and direct response. 1.04. What is the ratio of the Electricity production(% of total) of Sweden in 2002 to that in 2006?
Offer a terse response. 1.73. What is the ratio of the Electricity production(% of total) of Uruguay in 2002 to that in 2006?
Your response must be concise. 0.01. What is the ratio of the Electricity production(% of total) of East Asia (developing only) in 2002 to that in 2007?
Offer a very short reply. 2.06. What is the ratio of the Electricity production(% of total) in Denmark in 2002 to that in 2007?
Give a very brief answer. 1.12. What is the ratio of the Electricity production(% of total) of Sweden in 2002 to that in 2007?
Give a very brief answer. 2.78. What is the ratio of the Electricity production(% of total) of Uruguay in 2002 to that in 2007?
Provide a succinct answer. 0.03. What is the ratio of the Electricity production(% of total) in East Asia (developing only) in 2003 to that in 2004?
Ensure brevity in your answer.  0.9. What is the ratio of the Electricity production(% of total) in Denmark in 2003 to that in 2004?
Ensure brevity in your answer.  1.14. What is the ratio of the Electricity production(% of total) in Sweden in 2003 to that in 2004?
Offer a terse response. 2.22. What is the ratio of the Electricity production(% of total) of Uruguay in 2003 to that in 2004?
Offer a very short reply. 0.01. What is the ratio of the Electricity production(% of total) in East Asia (developing only) in 2003 to that in 2005?
Keep it short and to the point. 1.08. What is the ratio of the Electricity production(% of total) of Denmark in 2003 to that in 2005?
Offer a terse response. 1.22. What is the ratio of the Electricity production(% of total) of Sweden in 2003 to that in 2005?
Offer a terse response. 3.28. What is the ratio of the Electricity production(% of total) of Uruguay in 2003 to that in 2005?
Provide a short and direct response. 0.01. What is the ratio of the Electricity production(% of total) of East Asia (developing only) in 2003 to that in 2006?
Provide a succinct answer. 1.35. What is the ratio of the Electricity production(% of total) of Denmark in 2003 to that in 2006?
Give a very brief answer. 1.3. What is the ratio of the Electricity production(% of total) of Sweden in 2003 to that in 2006?
Keep it short and to the point. 2.45. What is the ratio of the Electricity production(% of total) of Uruguay in 2003 to that in 2006?
Make the answer very short. 0. What is the ratio of the Electricity production(% of total) in East Asia (developing only) in 2003 to that in 2007?
Your answer should be very brief. 1.92. What is the ratio of the Electricity production(% of total) in Denmark in 2003 to that in 2007?
Make the answer very short. 1.41. What is the ratio of the Electricity production(% of total) in Sweden in 2003 to that in 2007?
Keep it short and to the point. 3.95. What is the ratio of the Electricity production(% of total) in Uruguay in 2003 to that in 2007?
Provide a short and direct response. 0.01. What is the ratio of the Electricity production(% of total) of East Asia (developing only) in 2004 to that in 2005?
Your response must be concise. 1.2. What is the ratio of the Electricity production(% of total) of Denmark in 2004 to that in 2005?
Ensure brevity in your answer.  1.07. What is the ratio of the Electricity production(% of total) in Sweden in 2004 to that in 2005?
Your response must be concise. 1.48. What is the ratio of the Electricity production(% of total) in Uruguay in 2004 to that in 2005?
Ensure brevity in your answer.  1.48. What is the ratio of the Electricity production(% of total) of East Asia (developing only) in 2004 to that in 2006?
Give a very brief answer. 1.5. What is the ratio of the Electricity production(% of total) of Denmark in 2004 to that in 2006?
Give a very brief answer. 1.14. What is the ratio of the Electricity production(% of total) of Sweden in 2004 to that in 2006?
Provide a succinct answer. 1.11. What is the ratio of the Electricity production(% of total) in Uruguay in 2004 to that in 2006?
Your answer should be compact. 0.52. What is the ratio of the Electricity production(% of total) in East Asia (developing only) in 2004 to that in 2007?
Your response must be concise. 2.13. What is the ratio of the Electricity production(% of total) of Denmark in 2004 to that in 2007?
Your answer should be compact. 1.24. What is the ratio of the Electricity production(% of total) in Sweden in 2004 to that in 2007?
Provide a succinct answer. 1.78. What is the ratio of the Electricity production(% of total) of Uruguay in 2004 to that in 2007?
Make the answer very short. 1.42. What is the ratio of the Electricity production(% of total) of East Asia (developing only) in 2005 to that in 2006?
Provide a short and direct response. 1.25. What is the ratio of the Electricity production(% of total) of Denmark in 2005 to that in 2006?
Give a very brief answer. 1.07. What is the ratio of the Electricity production(% of total) in Sweden in 2005 to that in 2006?
Your answer should be compact. 0.75. What is the ratio of the Electricity production(% of total) in Uruguay in 2005 to that in 2006?
Offer a very short reply. 0.36. What is the ratio of the Electricity production(% of total) of East Asia (developing only) in 2005 to that in 2007?
Keep it short and to the point. 1.77. What is the ratio of the Electricity production(% of total) of Denmark in 2005 to that in 2007?
Your response must be concise. 1.16. What is the ratio of the Electricity production(% of total) in Sweden in 2005 to that in 2007?
Provide a succinct answer. 1.2. What is the ratio of the Electricity production(% of total) in Uruguay in 2005 to that in 2007?
Offer a very short reply. 0.96. What is the ratio of the Electricity production(% of total) in East Asia (developing only) in 2006 to that in 2007?
Offer a terse response. 1.42. What is the ratio of the Electricity production(% of total) of Denmark in 2006 to that in 2007?
Provide a succinct answer. 1.08. What is the ratio of the Electricity production(% of total) of Sweden in 2006 to that in 2007?
Give a very brief answer. 1.61. What is the ratio of the Electricity production(% of total) in Uruguay in 2006 to that in 2007?
Make the answer very short. 2.71. What is the difference between the highest and the second highest Electricity production(% of total) in East Asia (developing only)?
Your response must be concise. 0.01. What is the difference between the highest and the second highest Electricity production(% of total) of Denmark?
Give a very brief answer. 0.57. What is the difference between the highest and the second highest Electricity production(% of total) of Sweden?
Provide a succinct answer. 0.85. What is the difference between the highest and the second highest Electricity production(% of total) in Uruguay?
Keep it short and to the point. 16.69. What is the difference between the highest and the lowest Electricity production(% of total) of East Asia (developing only)?
Provide a succinct answer. 2.58. What is the difference between the highest and the lowest Electricity production(% of total) of Denmark?
Ensure brevity in your answer.  2.3. What is the difference between the highest and the lowest Electricity production(% of total) of Sweden?
Keep it short and to the point. 2.14. What is the difference between the highest and the lowest Electricity production(% of total) in Uruguay?
Your response must be concise. 34.94. 